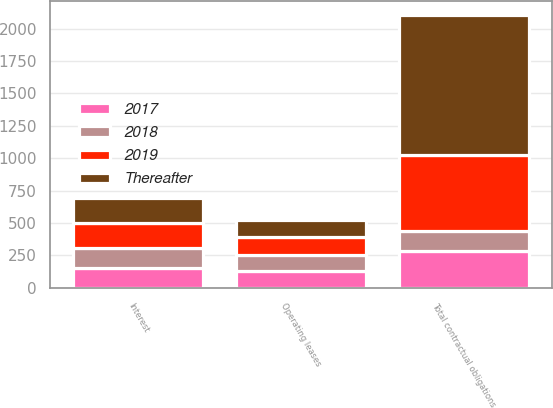<chart> <loc_0><loc_0><loc_500><loc_500><stacked_bar_chart><ecel><fcel>Interest<fcel>Operating leases<fcel>Total contractual obligations<nl><fcel>2019<fcel>196<fcel>134<fcel>588<nl><fcel>Thereafter<fcel>196<fcel>133<fcel>1079<nl><fcel>2017<fcel>152<fcel>131<fcel>285<nl><fcel>2018<fcel>152<fcel>125<fcel>152<nl></chart> 